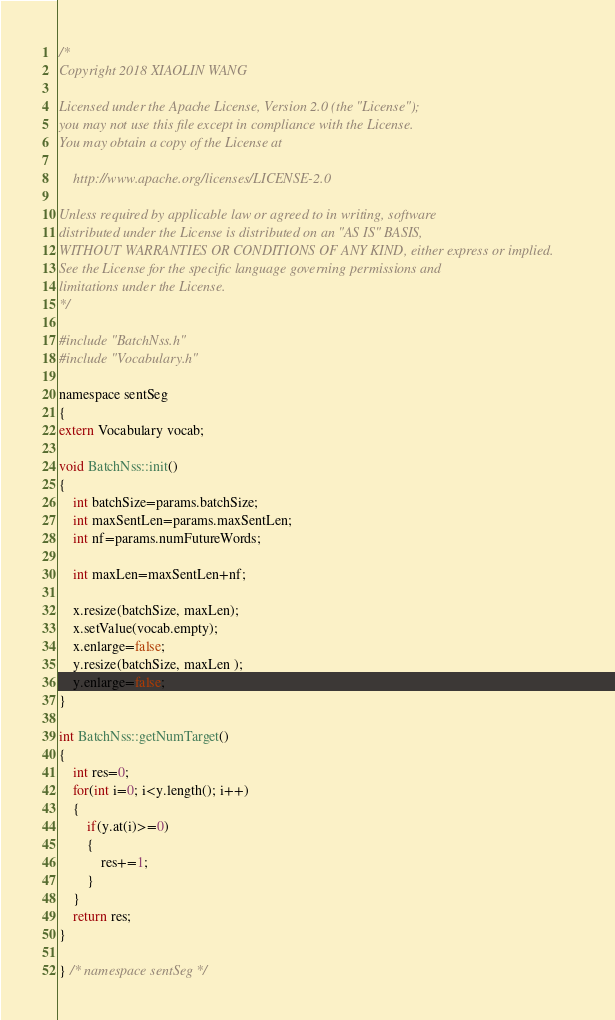<code> <loc_0><loc_0><loc_500><loc_500><_Cuda_>/*
Copyright 2018 XIAOLIN WANG 

Licensed under the Apache License, Version 2.0 (the "License");
you may not use this file except in compliance with the License.
You may obtain a copy of the License at

    http://www.apache.org/licenses/LICENSE-2.0

Unless required by applicable law or agreed to in writing, software
distributed under the License is distributed on an "AS IS" BASIS,
WITHOUT WARRANTIES OR CONDITIONS OF ANY KIND, either express or implied.
See the License for the specific language governing permissions and
limitations under the License.
*/

#include "BatchNss.h"
#include "Vocabulary.h"

namespace sentSeg
{
extern Vocabulary vocab;

void BatchNss::init()
{
	int batchSize=params.batchSize;
	int maxSentLen=params.maxSentLen;
	int nf=params.numFutureWords;

	int maxLen=maxSentLen+nf;

	x.resize(batchSize, maxLen);
	x.setValue(vocab.empty);
	x.enlarge=false;
	y.resize(batchSize, maxLen );
	y.enlarge=false;
}

int BatchNss::getNumTarget()
{
	int res=0;
	for(int i=0; i<y.length(); i++)
	{
		if(y.at(i)>=0)
		{
			res+=1;
		}
	}
	return res;
}

} /* namespace sentSeg */
</code> 